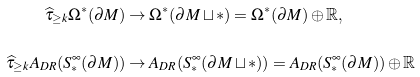<formula> <loc_0><loc_0><loc_500><loc_500>\widehat { \tau } _ { \geq k } \Omega ^ { \ast } ( \partial M ) & \rightarrow \Omega ^ { \ast } ( \partial M \sqcup \ast ) = \Omega ^ { \ast } ( \partial M ) \oplus \mathbb { R } , \\ \widehat { \tau } _ { \geq k } A _ { D R } ( S ^ { \infty } _ { \ast } ( \partial M ) ) & \rightarrow A _ { D R } ( S ^ { \infty } _ { \ast } ( \partial M \sqcup \ast ) ) = A _ { D R } ( S ^ { \infty } _ { \ast } ( \partial M ) ) \oplus \mathbb { R }</formula> 